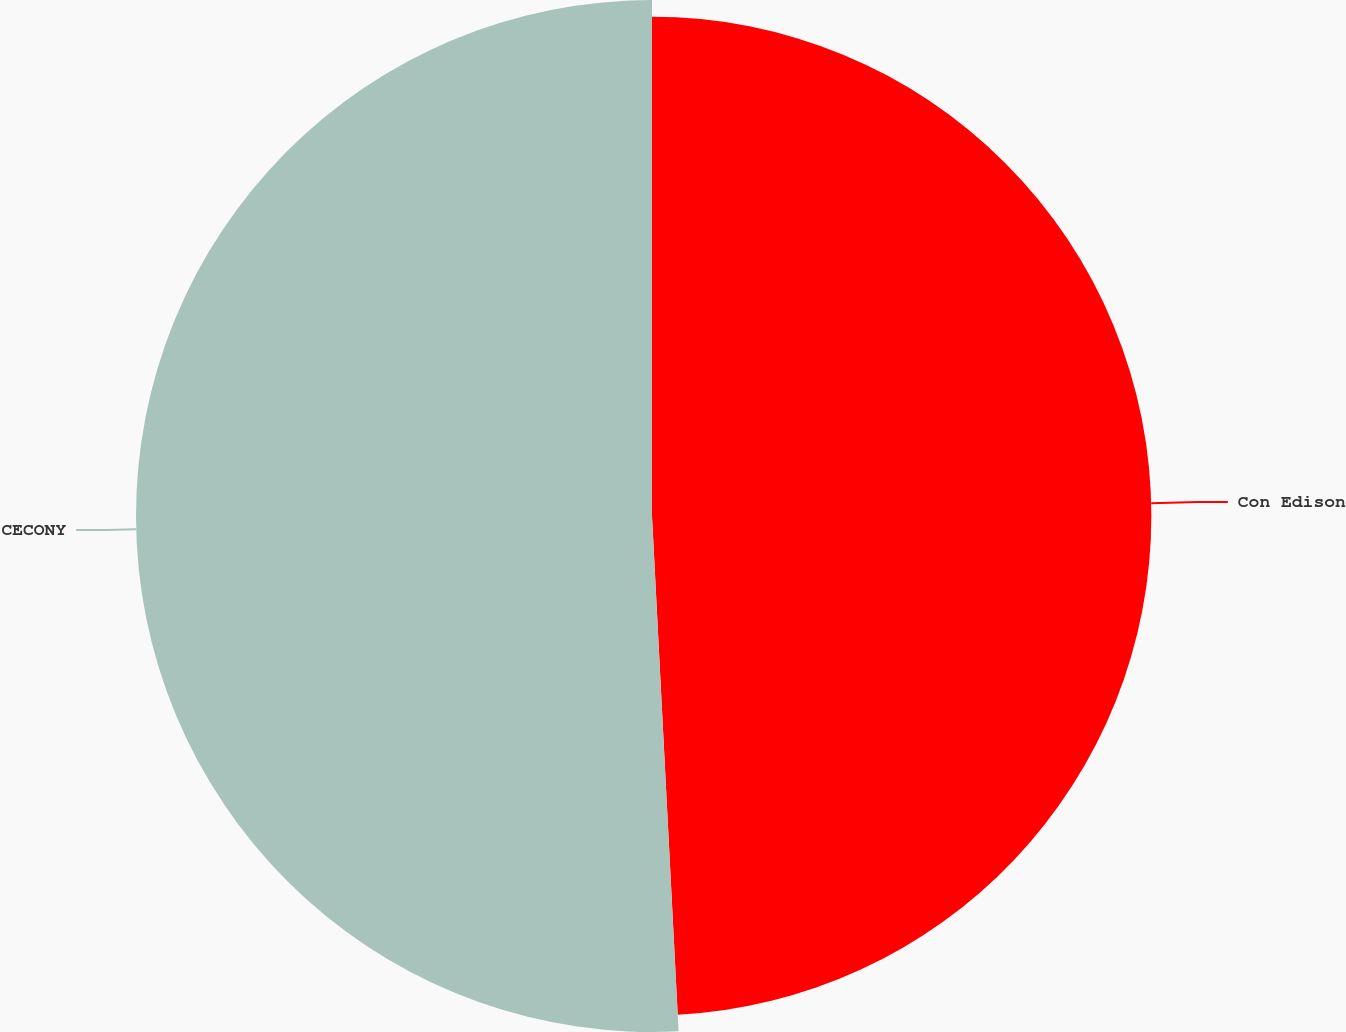Convert chart. <chart><loc_0><loc_0><loc_500><loc_500><pie_chart><fcel>Con Edison<fcel>CECONY<nl><fcel>49.18%<fcel>50.82%<nl></chart> 